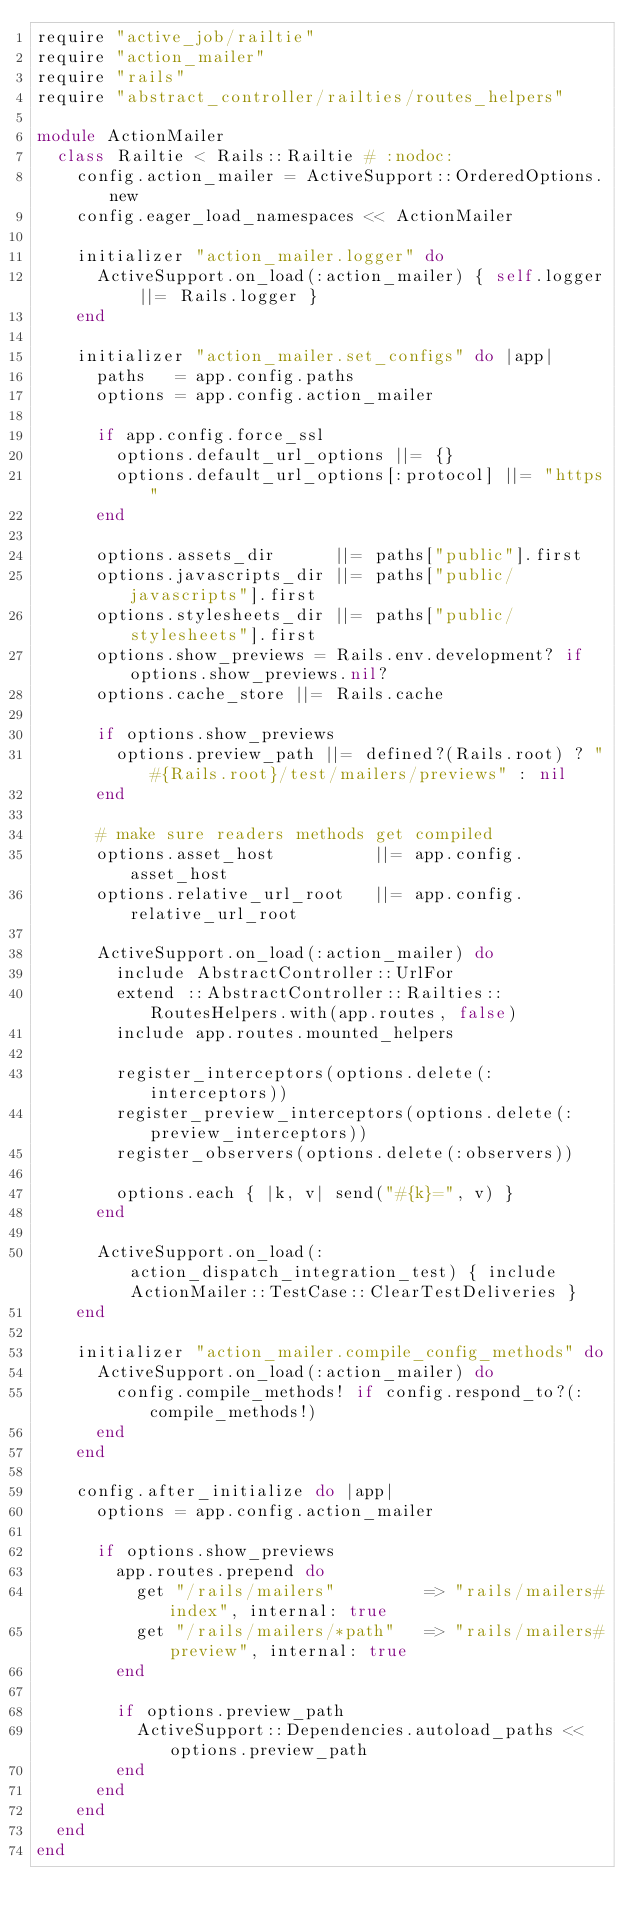<code> <loc_0><loc_0><loc_500><loc_500><_Ruby_>require "active_job/railtie"
require "action_mailer"
require "rails"
require "abstract_controller/railties/routes_helpers"

module ActionMailer
  class Railtie < Rails::Railtie # :nodoc:
    config.action_mailer = ActiveSupport::OrderedOptions.new
    config.eager_load_namespaces << ActionMailer

    initializer "action_mailer.logger" do
      ActiveSupport.on_load(:action_mailer) { self.logger ||= Rails.logger }
    end

    initializer "action_mailer.set_configs" do |app|
      paths   = app.config.paths
      options = app.config.action_mailer

      if app.config.force_ssl
        options.default_url_options ||= {}
        options.default_url_options[:protocol] ||= "https"
      end

      options.assets_dir      ||= paths["public"].first
      options.javascripts_dir ||= paths["public/javascripts"].first
      options.stylesheets_dir ||= paths["public/stylesheets"].first
      options.show_previews = Rails.env.development? if options.show_previews.nil?
      options.cache_store ||= Rails.cache

      if options.show_previews
        options.preview_path ||= defined?(Rails.root) ? "#{Rails.root}/test/mailers/previews" : nil
      end

      # make sure readers methods get compiled
      options.asset_host          ||= app.config.asset_host
      options.relative_url_root   ||= app.config.relative_url_root

      ActiveSupport.on_load(:action_mailer) do
        include AbstractController::UrlFor
        extend ::AbstractController::Railties::RoutesHelpers.with(app.routes, false)
        include app.routes.mounted_helpers

        register_interceptors(options.delete(:interceptors))
        register_preview_interceptors(options.delete(:preview_interceptors))
        register_observers(options.delete(:observers))

        options.each { |k, v| send("#{k}=", v) }
      end

      ActiveSupport.on_load(:action_dispatch_integration_test) { include ActionMailer::TestCase::ClearTestDeliveries }
    end

    initializer "action_mailer.compile_config_methods" do
      ActiveSupport.on_load(:action_mailer) do
        config.compile_methods! if config.respond_to?(:compile_methods!)
      end
    end

    config.after_initialize do |app|
      options = app.config.action_mailer

      if options.show_previews
        app.routes.prepend do
          get "/rails/mailers"         => "rails/mailers#index", internal: true
          get "/rails/mailers/*path"   => "rails/mailers#preview", internal: true
        end

        if options.preview_path
          ActiveSupport::Dependencies.autoload_paths << options.preview_path
        end
      end
    end
  end
end
</code> 